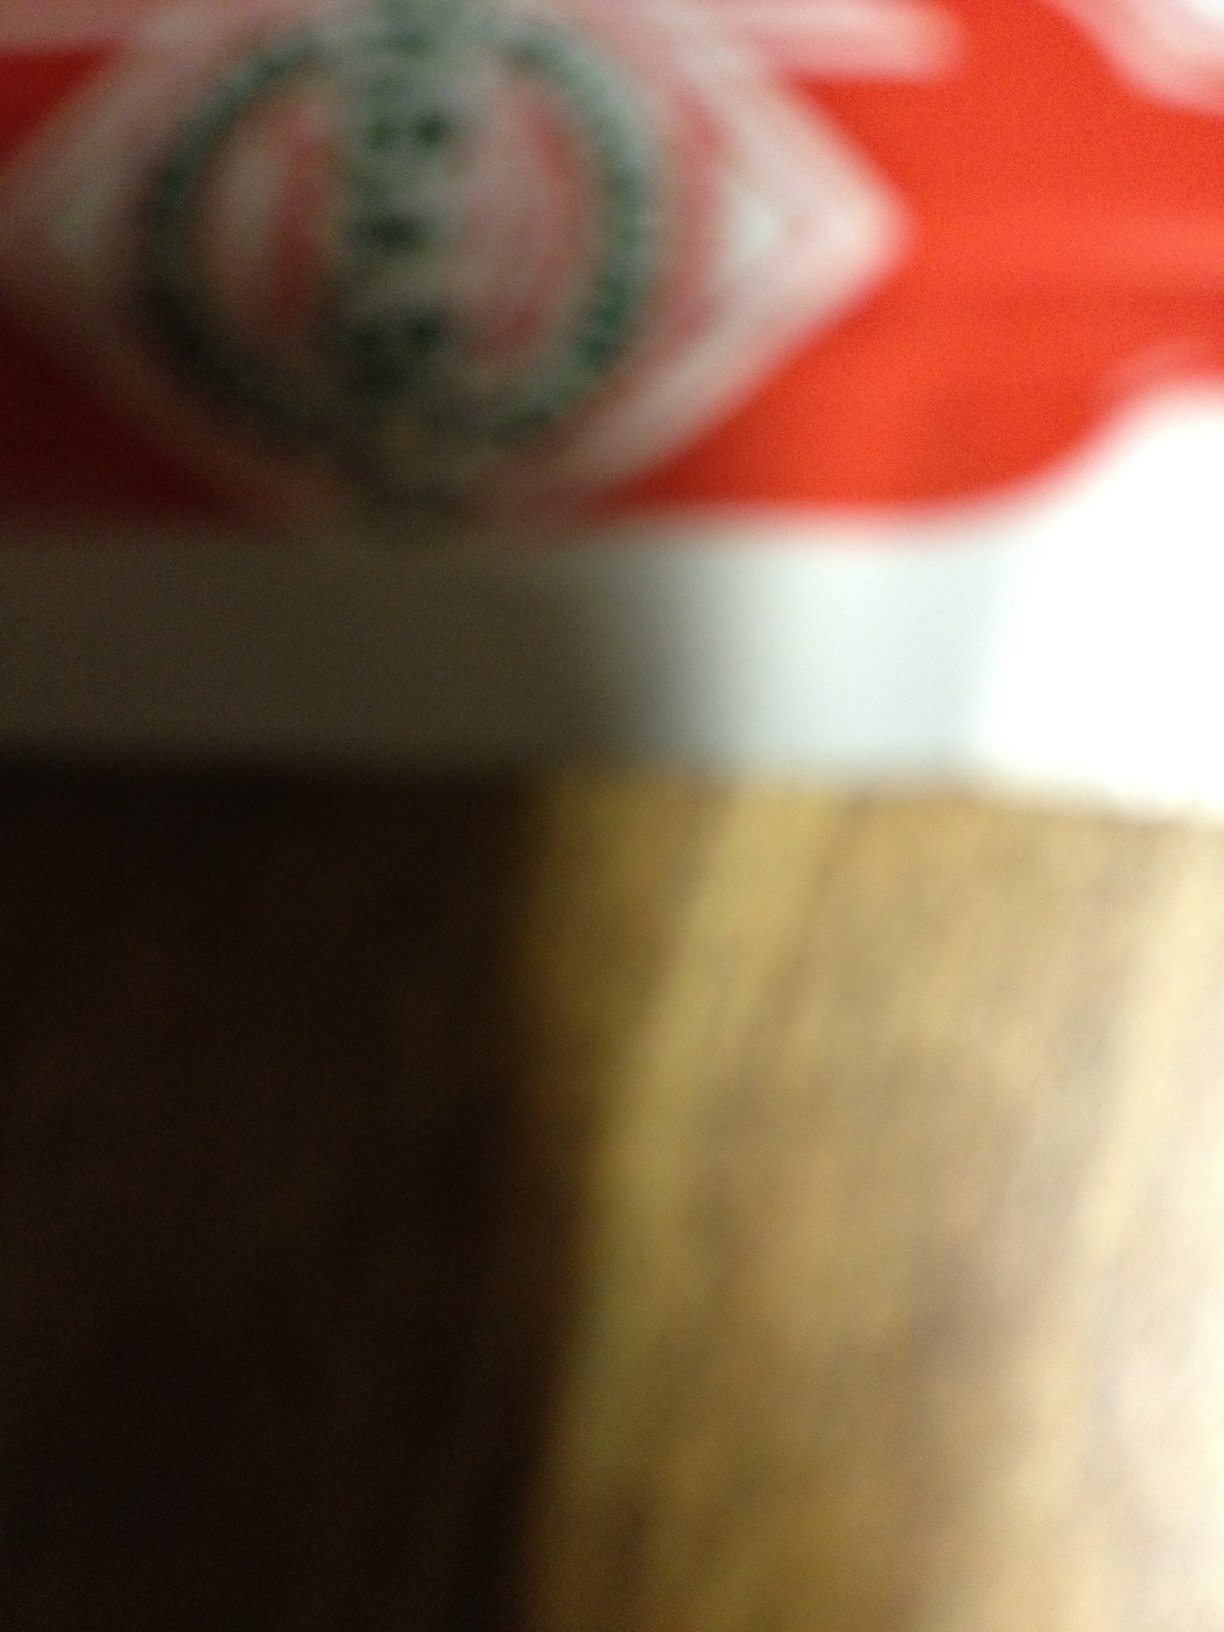Are there any discernible logos or text that can help identify this item? The image is too blurry to make out specific logos or text clearly. A clearer image or additional context might be helpful for a more accurate identification. 